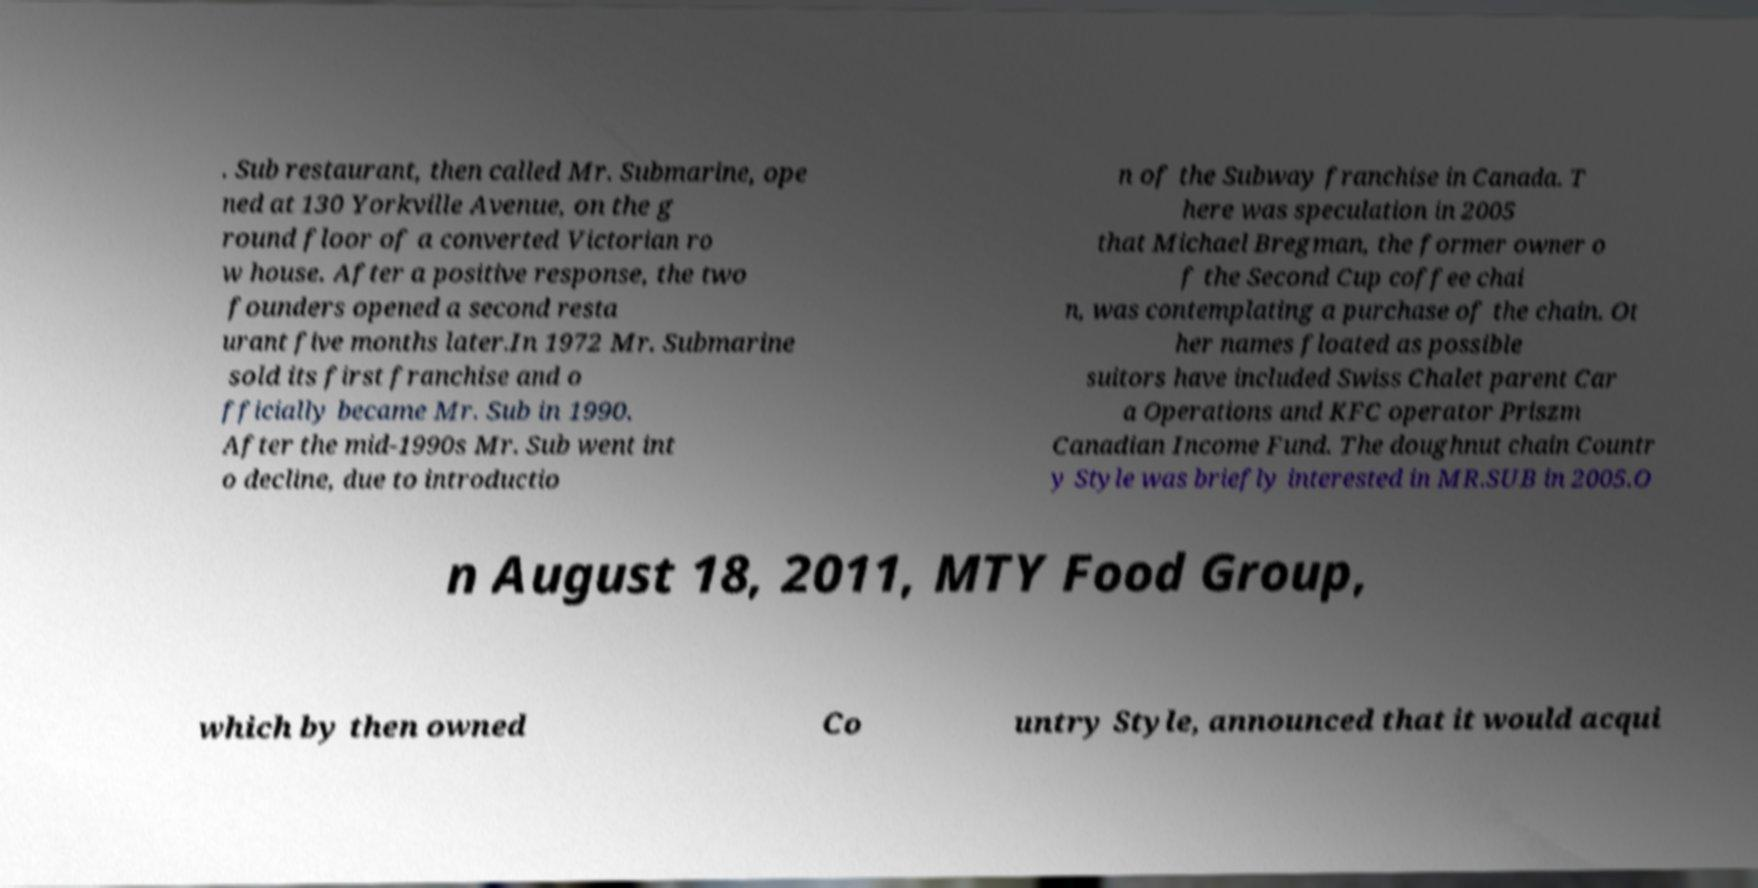Please identify and transcribe the text found in this image. . Sub restaurant, then called Mr. Submarine, ope ned at 130 Yorkville Avenue, on the g round floor of a converted Victorian ro w house. After a positive response, the two founders opened a second resta urant five months later.In 1972 Mr. Submarine sold its first franchise and o fficially became Mr. Sub in 1990. After the mid-1990s Mr. Sub went int o decline, due to introductio n of the Subway franchise in Canada. T here was speculation in 2005 that Michael Bregman, the former owner o f the Second Cup coffee chai n, was contemplating a purchase of the chain. Ot her names floated as possible suitors have included Swiss Chalet parent Car a Operations and KFC operator Priszm Canadian Income Fund. The doughnut chain Countr y Style was briefly interested in MR.SUB in 2005.O n August 18, 2011, MTY Food Group, which by then owned Co untry Style, announced that it would acqui 